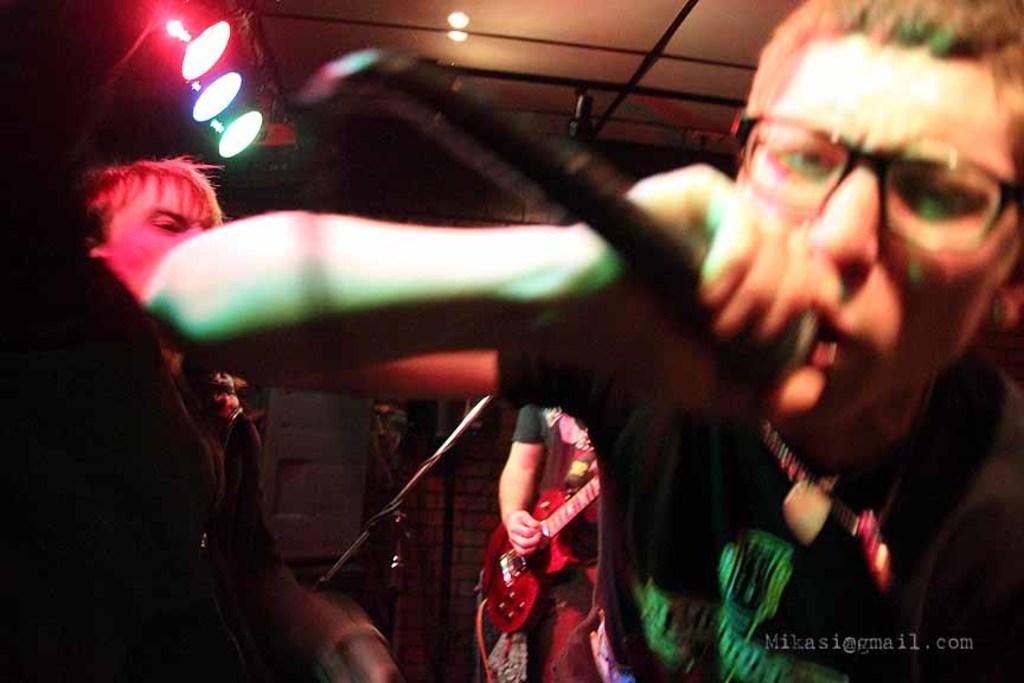How would you summarize this image in a sentence or two? In this image in the background i can see lights are visible. And a man wearing the t-shirt with black ,holding a mike and his mouth was open, and wearing a spectacles. And back side of him another man standing wearing black t- shirt and holding a guitar and left side there is a man wearing a black color t- shirt. 